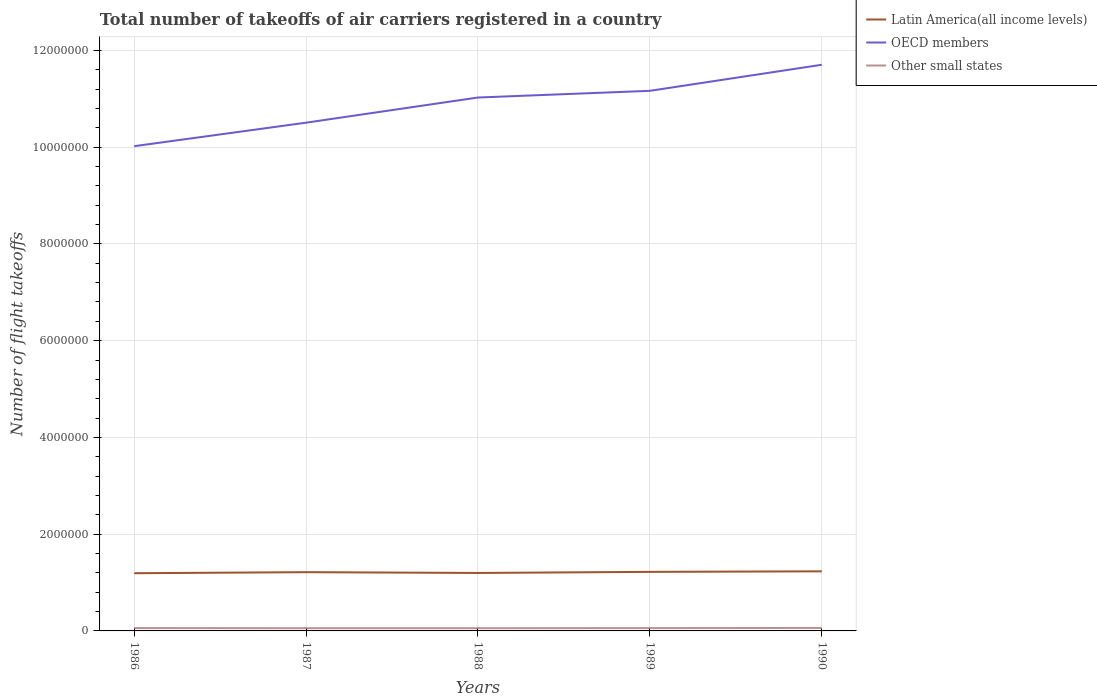How many different coloured lines are there?
Provide a succinct answer. 3. Is the number of lines equal to the number of legend labels?
Offer a very short reply. Yes. Across all years, what is the maximum total number of flight takeoffs in Other small states?
Your response must be concise. 5.59e+04. What is the total total number of flight takeoffs in OECD members in the graph?
Your answer should be compact. -6.58e+05. What is the difference between the highest and the second highest total number of flight takeoffs in Other small states?
Your answer should be compact. 5800. What is the difference between the highest and the lowest total number of flight takeoffs in Latin America(all income levels)?
Give a very brief answer. 3. How many lines are there?
Make the answer very short. 3. What is the difference between two consecutive major ticks on the Y-axis?
Provide a succinct answer. 2.00e+06. Are the values on the major ticks of Y-axis written in scientific E-notation?
Offer a very short reply. No. Does the graph contain any zero values?
Ensure brevity in your answer.  No. What is the title of the graph?
Provide a short and direct response. Total number of takeoffs of air carriers registered in a country. What is the label or title of the X-axis?
Offer a very short reply. Years. What is the label or title of the Y-axis?
Offer a very short reply. Number of flight takeoffs. What is the Number of flight takeoffs in Latin America(all income levels) in 1986?
Your answer should be very brief. 1.19e+06. What is the Number of flight takeoffs of OECD members in 1986?
Your response must be concise. 1.00e+07. What is the Number of flight takeoffs in Other small states in 1986?
Your response must be concise. 5.88e+04. What is the Number of flight takeoffs in Latin America(all income levels) in 1987?
Ensure brevity in your answer.  1.21e+06. What is the Number of flight takeoffs of OECD members in 1987?
Your response must be concise. 1.05e+07. What is the Number of flight takeoffs of Other small states in 1987?
Give a very brief answer. 5.59e+04. What is the Number of flight takeoffs of Latin America(all income levels) in 1988?
Provide a short and direct response. 1.20e+06. What is the Number of flight takeoffs in OECD members in 1988?
Your answer should be very brief. 1.10e+07. What is the Number of flight takeoffs in Other small states in 1988?
Ensure brevity in your answer.  5.60e+04. What is the Number of flight takeoffs in Latin America(all income levels) in 1989?
Keep it short and to the point. 1.22e+06. What is the Number of flight takeoffs of OECD members in 1989?
Make the answer very short. 1.12e+07. What is the Number of flight takeoffs in Other small states in 1989?
Provide a short and direct response. 5.80e+04. What is the Number of flight takeoffs in Latin America(all income levels) in 1990?
Provide a short and direct response. 1.23e+06. What is the Number of flight takeoffs in OECD members in 1990?
Ensure brevity in your answer.  1.17e+07. What is the Number of flight takeoffs of Other small states in 1990?
Your answer should be very brief. 6.17e+04. Across all years, what is the maximum Number of flight takeoffs in Latin America(all income levels)?
Offer a terse response. 1.23e+06. Across all years, what is the maximum Number of flight takeoffs in OECD members?
Make the answer very short. 1.17e+07. Across all years, what is the maximum Number of flight takeoffs of Other small states?
Offer a terse response. 6.17e+04. Across all years, what is the minimum Number of flight takeoffs of Latin America(all income levels)?
Your answer should be compact. 1.19e+06. Across all years, what is the minimum Number of flight takeoffs of OECD members?
Your answer should be compact. 1.00e+07. Across all years, what is the minimum Number of flight takeoffs in Other small states?
Your answer should be very brief. 5.59e+04. What is the total Number of flight takeoffs in Latin America(all income levels) in the graph?
Keep it short and to the point. 6.06e+06. What is the total Number of flight takeoffs in OECD members in the graph?
Make the answer very short. 5.44e+07. What is the total Number of flight takeoffs of Other small states in the graph?
Your answer should be compact. 2.90e+05. What is the difference between the Number of flight takeoffs of Latin America(all income levels) in 1986 and that in 1987?
Ensure brevity in your answer.  -2.19e+04. What is the difference between the Number of flight takeoffs in OECD members in 1986 and that in 1987?
Offer a very short reply. -4.86e+05. What is the difference between the Number of flight takeoffs of Other small states in 1986 and that in 1987?
Make the answer very short. 2900. What is the difference between the Number of flight takeoffs of Latin America(all income levels) in 1986 and that in 1988?
Give a very brief answer. -5600. What is the difference between the Number of flight takeoffs in OECD members in 1986 and that in 1988?
Make the answer very short. -1.01e+06. What is the difference between the Number of flight takeoffs of Other small states in 1986 and that in 1988?
Your answer should be compact. 2800. What is the difference between the Number of flight takeoffs of Latin America(all income levels) in 1986 and that in 1989?
Make the answer very short. -2.83e+04. What is the difference between the Number of flight takeoffs in OECD members in 1986 and that in 1989?
Make the answer very short. -1.14e+06. What is the difference between the Number of flight takeoffs in Other small states in 1986 and that in 1989?
Offer a very short reply. 800. What is the difference between the Number of flight takeoffs of Latin America(all income levels) in 1986 and that in 1990?
Provide a short and direct response. -3.93e+04. What is the difference between the Number of flight takeoffs in OECD members in 1986 and that in 1990?
Keep it short and to the point. -1.68e+06. What is the difference between the Number of flight takeoffs of Other small states in 1986 and that in 1990?
Your answer should be compact. -2900. What is the difference between the Number of flight takeoffs in Latin America(all income levels) in 1987 and that in 1988?
Offer a very short reply. 1.63e+04. What is the difference between the Number of flight takeoffs of OECD members in 1987 and that in 1988?
Make the answer very short. -5.20e+05. What is the difference between the Number of flight takeoffs of Other small states in 1987 and that in 1988?
Keep it short and to the point. -100. What is the difference between the Number of flight takeoffs in Latin America(all income levels) in 1987 and that in 1989?
Your response must be concise. -6400. What is the difference between the Number of flight takeoffs of OECD members in 1987 and that in 1989?
Give a very brief answer. -6.58e+05. What is the difference between the Number of flight takeoffs in Other small states in 1987 and that in 1989?
Provide a succinct answer. -2100. What is the difference between the Number of flight takeoffs of Latin America(all income levels) in 1987 and that in 1990?
Ensure brevity in your answer.  -1.74e+04. What is the difference between the Number of flight takeoffs in OECD members in 1987 and that in 1990?
Provide a short and direct response. -1.20e+06. What is the difference between the Number of flight takeoffs in Other small states in 1987 and that in 1990?
Give a very brief answer. -5800. What is the difference between the Number of flight takeoffs in Latin America(all income levels) in 1988 and that in 1989?
Make the answer very short. -2.27e+04. What is the difference between the Number of flight takeoffs of OECD members in 1988 and that in 1989?
Provide a succinct answer. -1.38e+05. What is the difference between the Number of flight takeoffs in Other small states in 1988 and that in 1989?
Offer a terse response. -2000. What is the difference between the Number of flight takeoffs in Latin America(all income levels) in 1988 and that in 1990?
Keep it short and to the point. -3.37e+04. What is the difference between the Number of flight takeoffs in OECD members in 1988 and that in 1990?
Your answer should be compact. -6.77e+05. What is the difference between the Number of flight takeoffs in Other small states in 1988 and that in 1990?
Your answer should be compact. -5700. What is the difference between the Number of flight takeoffs in Latin America(all income levels) in 1989 and that in 1990?
Your answer should be very brief. -1.10e+04. What is the difference between the Number of flight takeoffs in OECD members in 1989 and that in 1990?
Your answer should be compact. -5.39e+05. What is the difference between the Number of flight takeoffs in Other small states in 1989 and that in 1990?
Your response must be concise. -3700. What is the difference between the Number of flight takeoffs of Latin America(all income levels) in 1986 and the Number of flight takeoffs of OECD members in 1987?
Offer a very short reply. -9.31e+06. What is the difference between the Number of flight takeoffs in Latin America(all income levels) in 1986 and the Number of flight takeoffs in Other small states in 1987?
Keep it short and to the point. 1.14e+06. What is the difference between the Number of flight takeoffs of OECD members in 1986 and the Number of flight takeoffs of Other small states in 1987?
Make the answer very short. 9.96e+06. What is the difference between the Number of flight takeoffs in Latin America(all income levels) in 1986 and the Number of flight takeoffs in OECD members in 1988?
Your answer should be compact. -9.83e+06. What is the difference between the Number of flight takeoffs of Latin America(all income levels) in 1986 and the Number of flight takeoffs of Other small states in 1988?
Your response must be concise. 1.14e+06. What is the difference between the Number of flight takeoffs of OECD members in 1986 and the Number of flight takeoffs of Other small states in 1988?
Make the answer very short. 9.96e+06. What is the difference between the Number of flight takeoffs of Latin America(all income levels) in 1986 and the Number of flight takeoffs of OECD members in 1989?
Ensure brevity in your answer.  -9.97e+06. What is the difference between the Number of flight takeoffs of Latin America(all income levels) in 1986 and the Number of flight takeoffs of Other small states in 1989?
Your response must be concise. 1.13e+06. What is the difference between the Number of flight takeoffs of OECD members in 1986 and the Number of flight takeoffs of Other small states in 1989?
Make the answer very short. 9.96e+06. What is the difference between the Number of flight takeoffs of Latin America(all income levels) in 1986 and the Number of flight takeoffs of OECD members in 1990?
Offer a very short reply. -1.05e+07. What is the difference between the Number of flight takeoffs of Latin America(all income levels) in 1986 and the Number of flight takeoffs of Other small states in 1990?
Provide a succinct answer. 1.13e+06. What is the difference between the Number of flight takeoffs of OECD members in 1986 and the Number of flight takeoffs of Other small states in 1990?
Your answer should be compact. 9.96e+06. What is the difference between the Number of flight takeoffs of Latin America(all income levels) in 1987 and the Number of flight takeoffs of OECD members in 1988?
Offer a terse response. -9.81e+06. What is the difference between the Number of flight takeoffs in Latin America(all income levels) in 1987 and the Number of flight takeoffs in Other small states in 1988?
Give a very brief answer. 1.16e+06. What is the difference between the Number of flight takeoffs in OECD members in 1987 and the Number of flight takeoffs in Other small states in 1988?
Your answer should be very brief. 1.04e+07. What is the difference between the Number of flight takeoffs of Latin America(all income levels) in 1987 and the Number of flight takeoffs of OECD members in 1989?
Ensure brevity in your answer.  -9.95e+06. What is the difference between the Number of flight takeoffs in Latin America(all income levels) in 1987 and the Number of flight takeoffs in Other small states in 1989?
Your response must be concise. 1.16e+06. What is the difference between the Number of flight takeoffs in OECD members in 1987 and the Number of flight takeoffs in Other small states in 1989?
Offer a very short reply. 1.04e+07. What is the difference between the Number of flight takeoffs of Latin America(all income levels) in 1987 and the Number of flight takeoffs of OECD members in 1990?
Offer a terse response. -1.05e+07. What is the difference between the Number of flight takeoffs in Latin America(all income levels) in 1987 and the Number of flight takeoffs in Other small states in 1990?
Keep it short and to the point. 1.15e+06. What is the difference between the Number of flight takeoffs in OECD members in 1987 and the Number of flight takeoffs in Other small states in 1990?
Offer a terse response. 1.04e+07. What is the difference between the Number of flight takeoffs of Latin America(all income levels) in 1988 and the Number of flight takeoffs of OECD members in 1989?
Offer a terse response. -9.97e+06. What is the difference between the Number of flight takeoffs in Latin America(all income levels) in 1988 and the Number of flight takeoffs in Other small states in 1989?
Offer a terse response. 1.14e+06. What is the difference between the Number of flight takeoffs in OECD members in 1988 and the Number of flight takeoffs in Other small states in 1989?
Offer a very short reply. 1.10e+07. What is the difference between the Number of flight takeoffs of Latin America(all income levels) in 1988 and the Number of flight takeoffs of OECD members in 1990?
Give a very brief answer. -1.05e+07. What is the difference between the Number of flight takeoffs of Latin America(all income levels) in 1988 and the Number of flight takeoffs of Other small states in 1990?
Give a very brief answer. 1.14e+06. What is the difference between the Number of flight takeoffs of OECD members in 1988 and the Number of flight takeoffs of Other small states in 1990?
Provide a succinct answer. 1.10e+07. What is the difference between the Number of flight takeoffs of Latin America(all income levels) in 1989 and the Number of flight takeoffs of OECD members in 1990?
Give a very brief answer. -1.05e+07. What is the difference between the Number of flight takeoffs of Latin America(all income levels) in 1989 and the Number of flight takeoffs of Other small states in 1990?
Offer a very short reply. 1.16e+06. What is the difference between the Number of flight takeoffs in OECD members in 1989 and the Number of flight takeoffs in Other small states in 1990?
Offer a very short reply. 1.11e+07. What is the average Number of flight takeoffs of Latin America(all income levels) per year?
Your response must be concise. 1.21e+06. What is the average Number of flight takeoffs of OECD members per year?
Ensure brevity in your answer.  1.09e+07. What is the average Number of flight takeoffs in Other small states per year?
Provide a short and direct response. 5.81e+04. In the year 1986, what is the difference between the Number of flight takeoffs of Latin America(all income levels) and Number of flight takeoffs of OECD members?
Provide a short and direct response. -8.83e+06. In the year 1986, what is the difference between the Number of flight takeoffs in Latin America(all income levels) and Number of flight takeoffs in Other small states?
Your answer should be very brief. 1.13e+06. In the year 1986, what is the difference between the Number of flight takeoffs in OECD members and Number of flight takeoffs in Other small states?
Provide a succinct answer. 9.96e+06. In the year 1987, what is the difference between the Number of flight takeoffs of Latin America(all income levels) and Number of flight takeoffs of OECD members?
Offer a terse response. -9.29e+06. In the year 1987, what is the difference between the Number of flight takeoffs of Latin America(all income levels) and Number of flight takeoffs of Other small states?
Provide a succinct answer. 1.16e+06. In the year 1987, what is the difference between the Number of flight takeoffs of OECD members and Number of flight takeoffs of Other small states?
Give a very brief answer. 1.04e+07. In the year 1988, what is the difference between the Number of flight takeoffs in Latin America(all income levels) and Number of flight takeoffs in OECD members?
Your answer should be compact. -9.83e+06. In the year 1988, what is the difference between the Number of flight takeoffs in Latin America(all income levels) and Number of flight takeoffs in Other small states?
Ensure brevity in your answer.  1.14e+06. In the year 1988, what is the difference between the Number of flight takeoffs in OECD members and Number of flight takeoffs in Other small states?
Provide a short and direct response. 1.10e+07. In the year 1989, what is the difference between the Number of flight takeoffs in Latin America(all income levels) and Number of flight takeoffs in OECD members?
Ensure brevity in your answer.  -9.94e+06. In the year 1989, what is the difference between the Number of flight takeoffs in Latin America(all income levels) and Number of flight takeoffs in Other small states?
Offer a terse response. 1.16e+06. In the year 1989, what is the difference between the Number of flight takeoffs of OECD members and Number of flight takeoffs of Other small states?
Provide a succinct answer. 1.11e+07. In the year 1990, what is the difference between the Number of flight takeoffs in Latin America(all income levels) and Number of flight takeoffs in OECD members?
Your response must be concise. -1.05e+07. In the year 1990, what is the difference between the Number of flight takeoffs of Latin America(all income levels) and Number of flight takeoffs of Other small states?
Your response must be concise. 1.17e+06. In the year 1990, what is the difference between the Number of flight takeoffs of OECD members and Number of flight takeoffs of Other small states?
Your answer should be very brief. 1.16e+07. What is the ratio of the Number of flight takeoffs in OECD members in 1986 to that in 1987?
Your answer should be very brief. 0.95. What is the ratio of the Number of flight takeoffs of Other small states in 1986 to that in 1987?
Ensure brevity in your answer.  1.05. What is the ratio of the Number of flight takeoffs of Latin America(all income levels) in 1986 to that in 1988?
Provide a short and direct response. 1. What is the ratio of the Number of flight takeoffs of OECD members in 1986 to that in 1988?
Make the answer very short. 0.91. What is the ratio of the Number of flight takeoffs in Other small states in 1986 to that in 1988?
Your response must be concise. 1.05. What is the ratio of the Number of flight takeoffs of Latin America(all income levels) in 1986 to that in 1989?
Your response must be concise. 0.98. What is the ratio of the Number of flight takeoffs in OECD members in 1986 to that in 1989?
Make the answer very short. 0.9. What is the ratio of the Number of flight takeoffs of Other small states in 1986 to that in 1989?
Your answer should be very brief. 1.01. What is the ratio of the Number of flight takeoffs in Latin America(all income levels) in 1986 to that in 1990?
Provide a succinct answer. 0.97. What is the ratio of the Number of flight takeoffs of OECD members in 1986 to that in 1990?
Provide a succinct answer. 0.86. What is the ratio of the Number of flight takeoffs in Other small states in 1986 to that in 1990?
Ensure brevity in your answer.  0.95. What is the ratio of the Number of flight takeoffs of Latin America(all income levels) in 1987 to that in 1988?
Offer a terse response. 1.01. What is the ratio of the Number of flight takeoffs in OECD members in 1987 to that in 1988?
Provide a short and direct response. 0.95. What is the ratio of the Number of flight takeoffs of Other small states in 1987 to that in 1988?
Make the answer very short. 1. What is the ratio of the Number of flight takeoffs of OECD members in 1987 to that in 1989?
Keep it short and to the point. 0.94. What is the ratio of the Number of flight takeoffs of Other small states in 1987 to that in 1989?
Make the answer very short. 0.96. What is the ratio of the Number of flight takeoffs in Latin America(all income levels) in 1987 to that in 1990?
Keep it short and to the point. 0.99. What is the ratio of the Number of flight takeoffs of OECD members in 1987 to that in 1990?
Your answer should be compact. 0.9. What is the ratio of the Number of flight takeoffs in Other small states in 1987 to that in 1990?
Provide a succinct answer. 0.91. What is the ratio of the Number of flight takeoffs in Latin America(all income levels) in 1988 to that in 1989?
Ensure brevity in your answer.  0.98. What is the ratio of the Number of flight takeoffs in OECD members in 1988 to that in 1989?
Provide a succinct answer. 0.99. What is the ratio of the Number of flight takeoffs of Other small states in 1988 to that in 1989?
Keep it short and to the point. 0.97. What is the ratio of the Number of flight takeoffs in Latin America(all income levels) in 1988 to that in 1990?
Your answer should be very brief. 0.97. What is the ratio of the Number of flight takeoffs of OECD members in 1988 to that in 1990?
Ensure brevity in your answer.  0.94. What is the ratio of the Number of flight takeoffs in Other small states in 1988 to that in 1990?
Provide a short and direct response. 0.91. What is the ratio of the Number of flight takeoffs of Latin America(all income levels) in 1989 to that in 1990?
Your response must be concise. 0.99. What is the ratio of the Number of flight takeoffs in OECD members in 1989 to that in 1990?
Make the answer very short. 0.95. What is the difference between the highest and the second highest Number of flight takeoffs in Latin America(all income levels)?
Your answer should be very brief. 1.10e+04. What is the difference between the highest and the second highest Number of flight takeoffs in OECD members?
Offer a very short reply. 5.39e+05. What is the difference between the highest and the second highest Number of flight takeoffs in Other small states?
Your answer should be very brief. 2900. What is the difference between the highest and the lowest Number of flight takeoffs of Latin America(all income levels)?
Offer a terse response. 3.93e+04. What is the difference between the highest and the lowest Number of flight takeoffs in OECD members?
Your response must be concise. 1.68e+06. What is the difference between the highest and the lowest Number of flight takeoffs in Other small states?
Offer a terse response. 5800. 